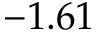Convert formula to latex. <formula><loc_0><loc_0><loc_500><loc_500>- 1 . 6 1</formula> 